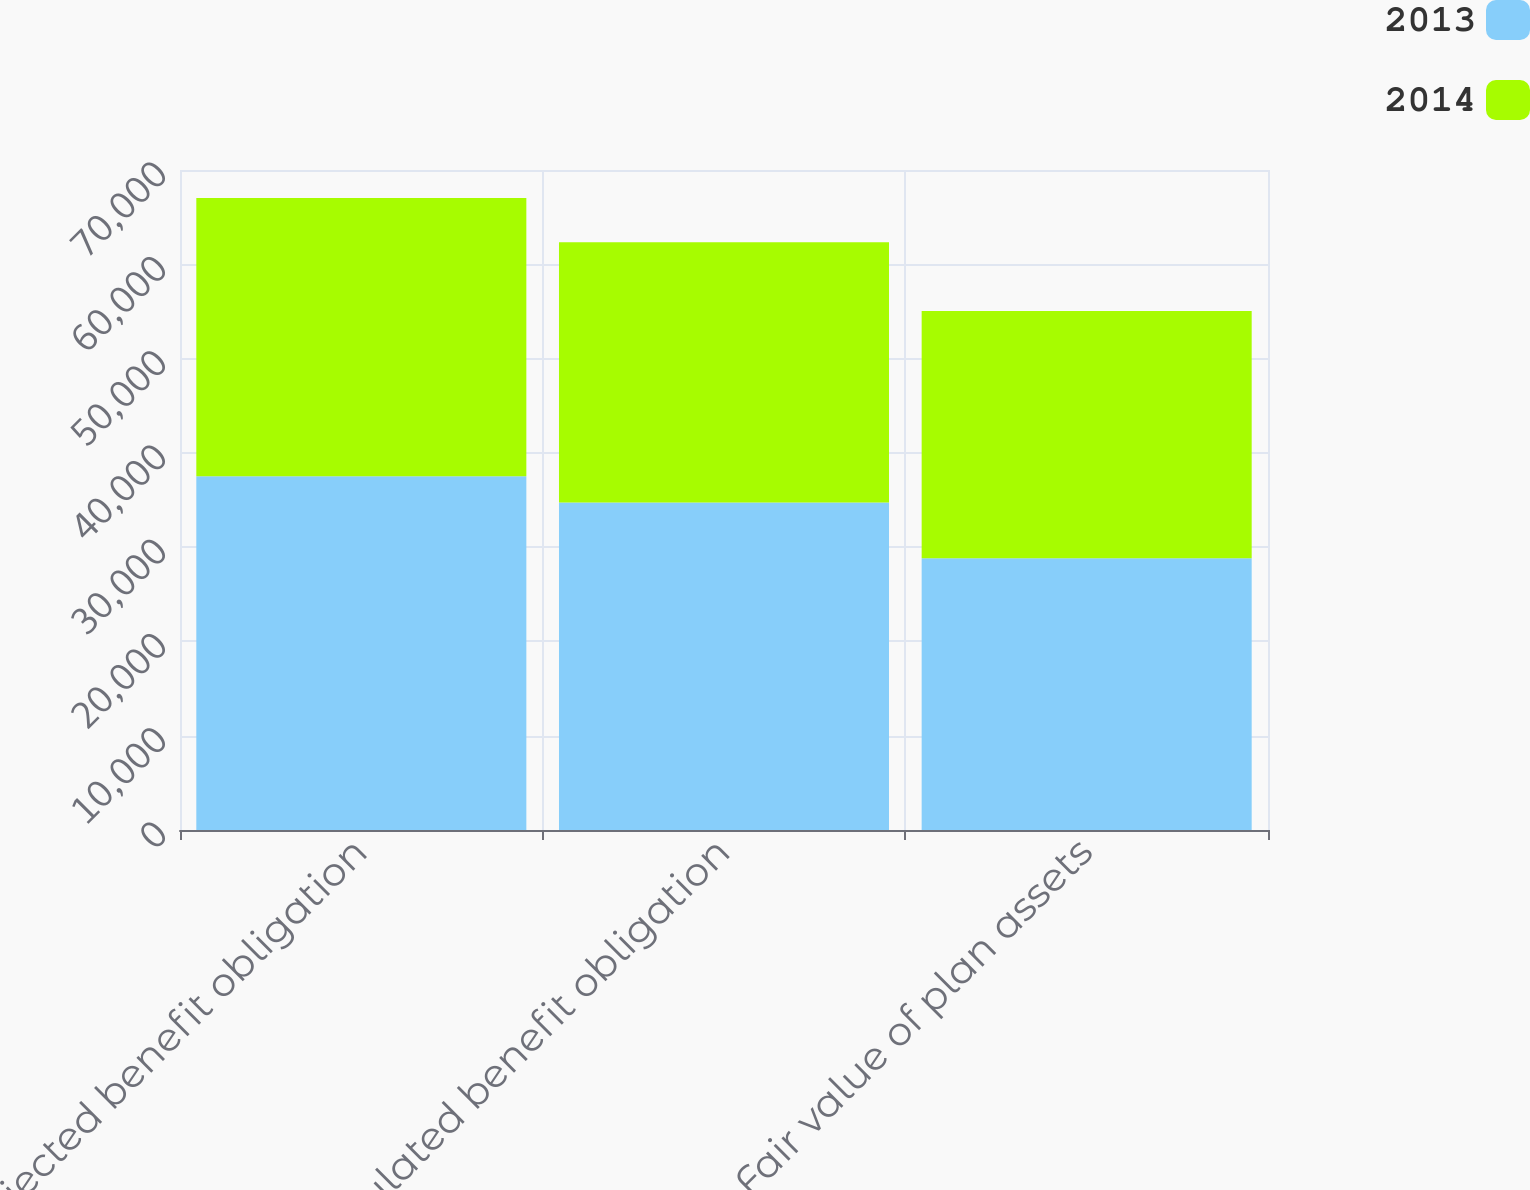Convert chart to OTSL. <chart><loc_0><loc_0><loc_500><loc_500><stacked_bar_chart><ecel><fcel>Projected benefit obligation<fcel>Accumulated benefit obligation<fcel>Fair value of plan assets<nl><fcel>2013<fcel>37521<fcel>34725<fcel>28828<nl><fcel>2014<fcel>29508<fcel>27623<fcel>26224<nl></chart> 